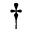Convert formula to latex. <formula><loc_0><loc_0><loc_500><loc_500>^ { \dagger }</formula> 